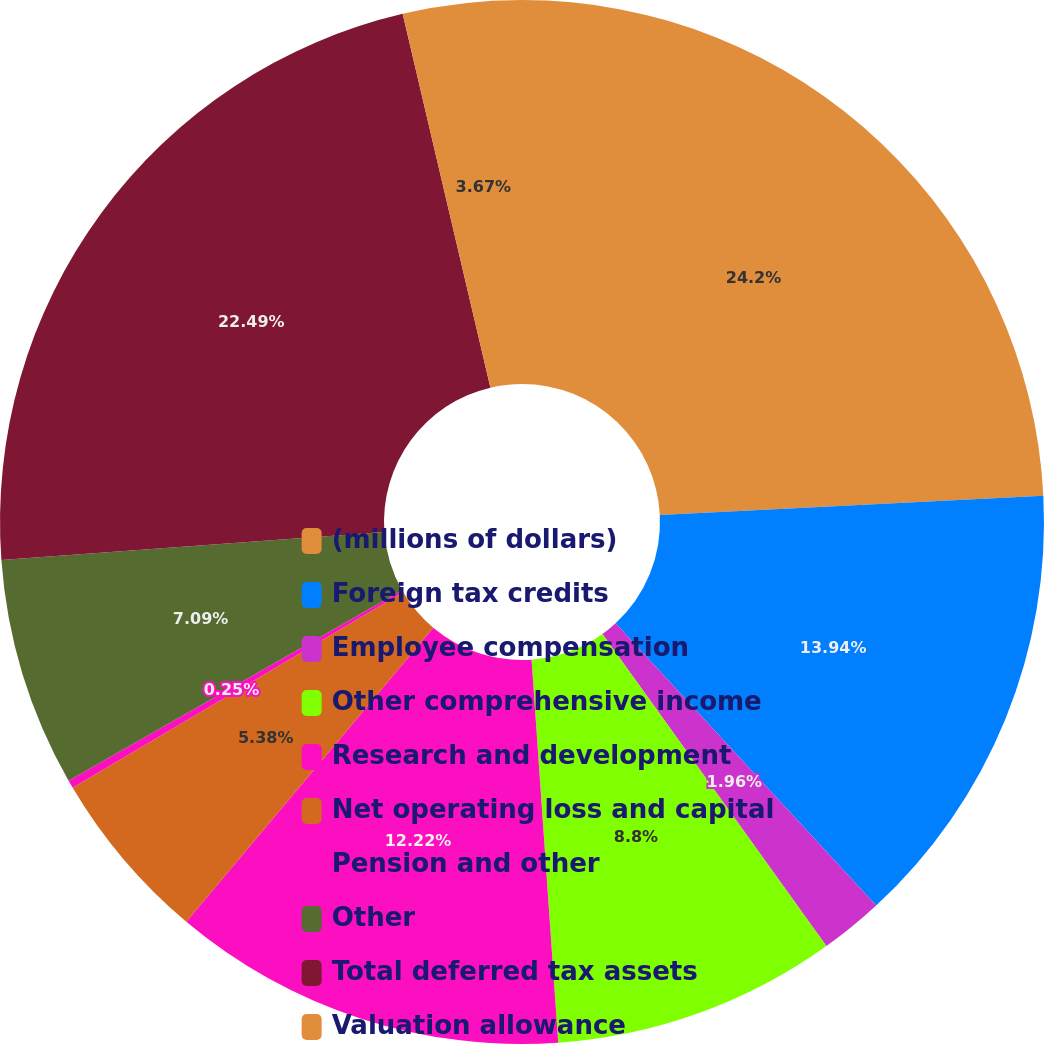Convert chart. <chart><loc_0><loc_0><loc_500><loc_500><pie_chart><fcel>(millions of dollars)<fcel>Foreign tax credits<fcel>Employee compensation<fcel>Other comprehensive income<fcel>Research and development<fcel>Net operating loss and capital<fcel>Pension and other<fcel>Other<fcel>Total deferred tax assets<fcel>Valuation allowance<nl><fcel>24.19%<fcel>13.93%<fcel>1.96%<fcel>8.8%<fcel>12.22%<fcel>5.38%<fcel>0.25%<fcel>7.09%<fcel>22.48%<fcel>3.67%<nl></chart> 